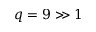<formula> <loc_0><loc_0><loc_500><loc_500>q = 9 \gg 1</formula> 